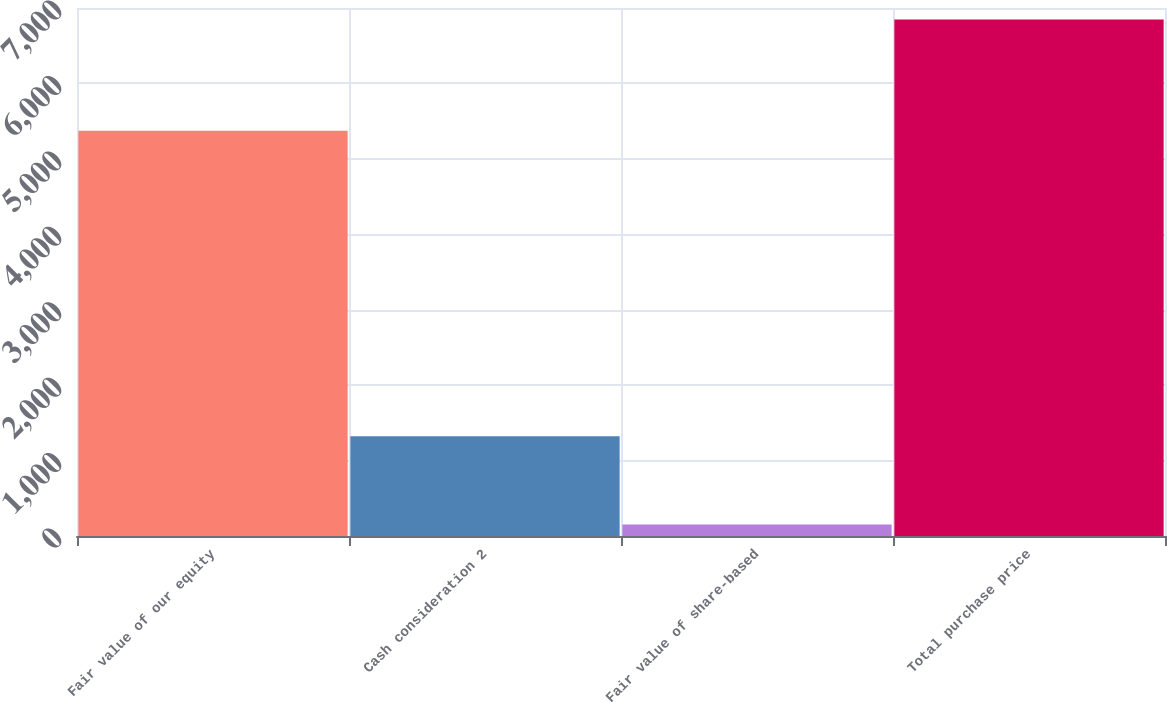Convert chart to OTSL. <chart><loc_0><loc_0><loc_500><loc_500><bar_chart><fcel>Fair value of our equity<fcel>Cash consideration 2<fcel>Fair value of share-based<fcel>Total purchase price<nl><fcel>5373<fcel>1321<fcel>154<fcel>6848<nl></chart> 